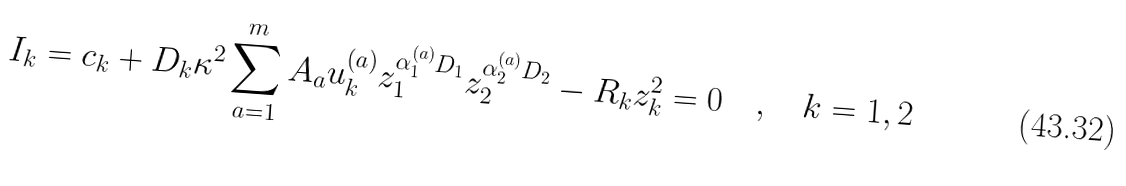Convert formula to latex. <formula><loc_0><loc_0><loc_500><loc_500>I _ { k } = c _ { k } + D _ { k } \kappa ^ { 2 } \sum _ { a = 1 } ^ { m } A _ { a } u _ { k } ^ { ( a ) } z _ { 1 } ^ { \alpha _ { 1 } ^ { ( a ) } D _ { 1 } } z _ { 2 } ^ { \alpha _ { 2 } ^ { ( a ) } D _ { 2 } } - R _ { k } z _ { k } ^ { 2 } = 0 \quad , \quad k = 1 , 2</formula> 